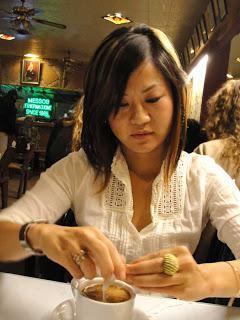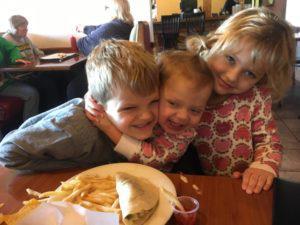The first image is the image on the left, the second image is the image on the right. Assess this claim about the two images: "At least one of the pictures shows a person holding a fork or a spoon.". Correct or not? Answer yes or no. No. The first image is the image on the left, the second image is the image on the right. Given the left and right images, does the statement "The left image shows a young man with dark hair on his head and facial hair, sitting behind a table and raising one hand to his mouth." hold true? Answer yes or no. No. 